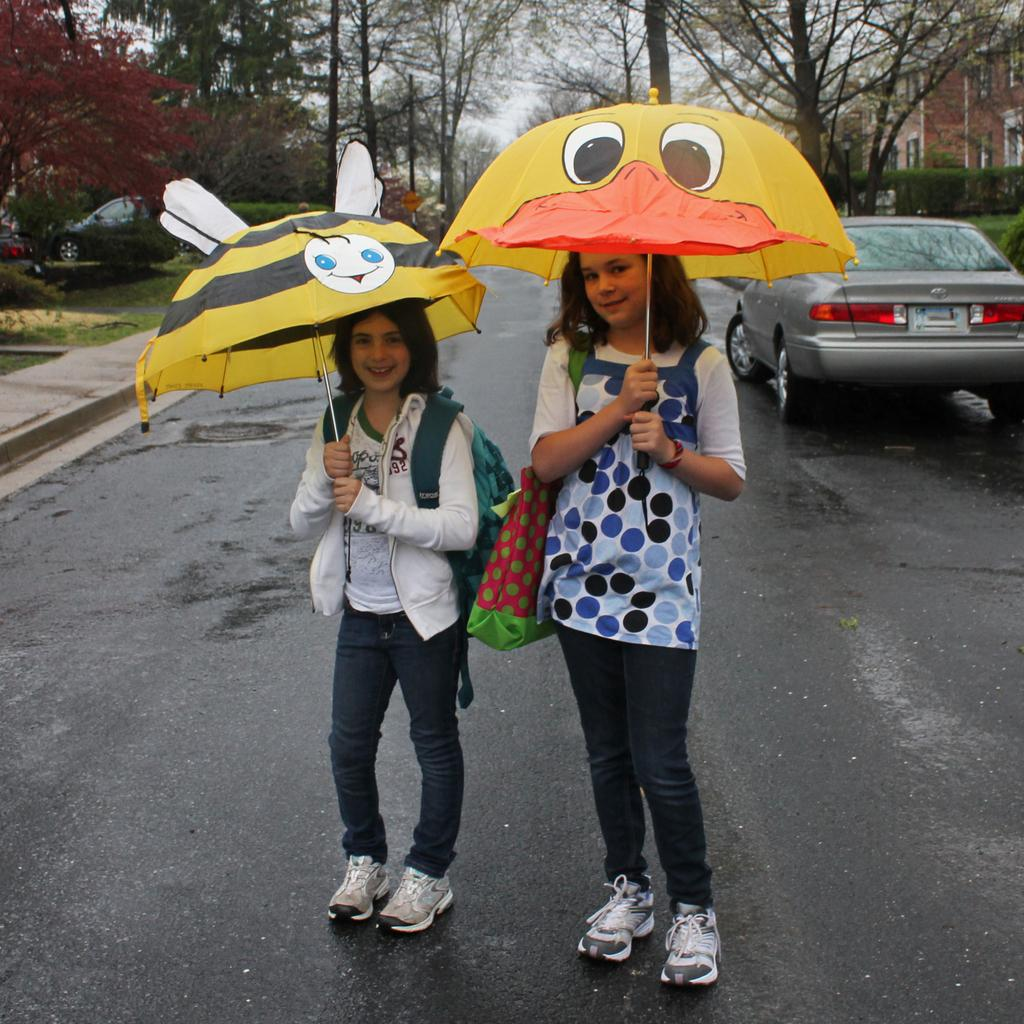How many girls are in the image? There are two girls in the image. What are the girls doing in the image? The girls are standing on the road and holding umbrellas. What can be seen in the background of the image? There are cars, trees, a building, and the sky visible in the background. What type of government is depicted in the image? There is no depiction of a government in the image; it features two girls standing on the road with umbrellas. What kind of seed can be seen growing on the tree in the image? There is no tree present in the image, so it is not possible to determine what kind of seed might be growing on it. 